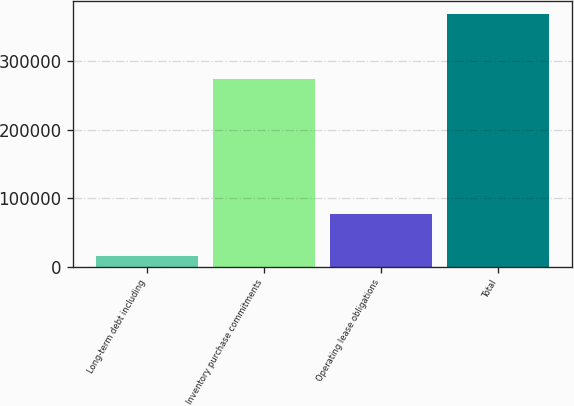Convert chart to OTSL. <chart><loc_0><loc_0><loc_500><loc_500><bar_chart><fcel>Long-term debt including<fcel>Inventory purchase commitments<fcel>Operating lease obligations<fcel>Total<nl><fcel>15920<fcel>273282<fcel>77453<fcel>369338<nl></chart> 